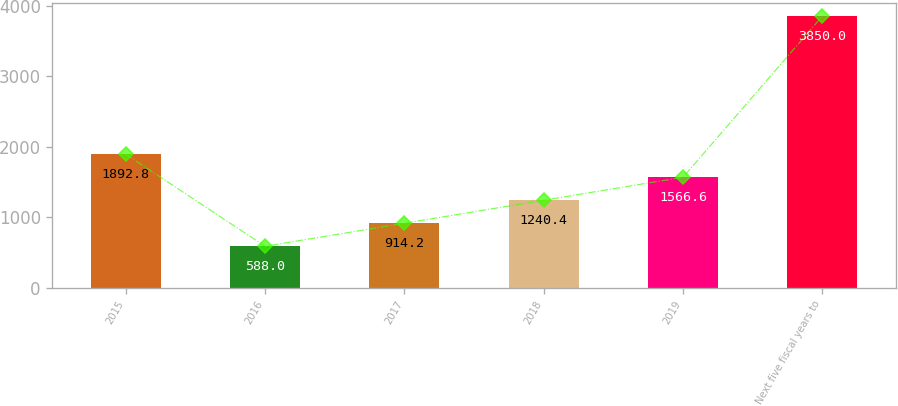Convert chart. <chart><loc_0><loc_0><loc_500><loc_500><bar_chart><fcel>2015<fcel>2016<fcel>2017<fcel>2018<fcel>2019<fcel>Next five fiscal years to<nl><fcel>1892.8<fcel>588<fcel>914.2<fcel>1240.4<fcel>1566.6<fcel>3850<nl></chart> 